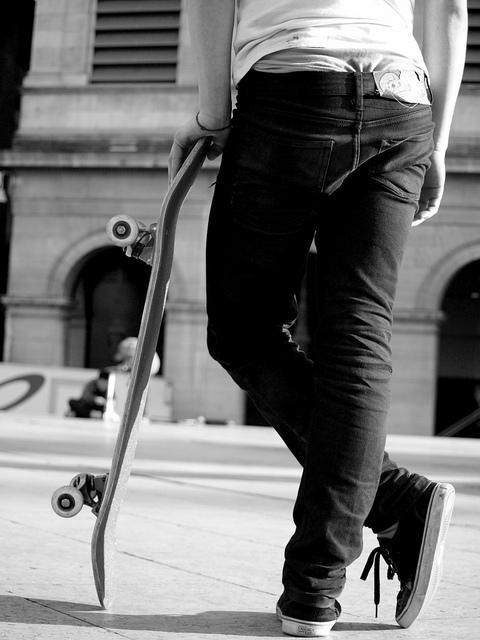What can the object the person is leaning on be used for? Please explain your reasoning. transportation. The person can use the skateboard to get around. 